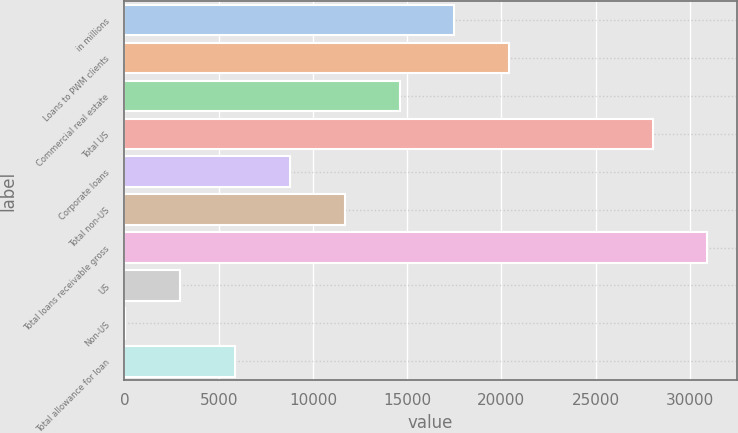Convert chart. <chart><loc_0><loc_0><loc_500><loc_500><bar_chart><fcel>in millions<fcel>Loans to PWM clients<fcel>Commercial real estate<fcel>Total US<fcel>Corporate loans<fcel>Total non-US<fcel>Total loans receivable gross<fcel>US<fcel>Non-US<fcel>Total allowance for loan<nl><fcel>17508.8<fcel>20423.1<fcel>14594.5<fcel>28017<fcel>8765.9<fcel>11680.2<fcel>30931.3<fcel>2937.3<fcel>23<fcel>5851.6<nl></chart> 